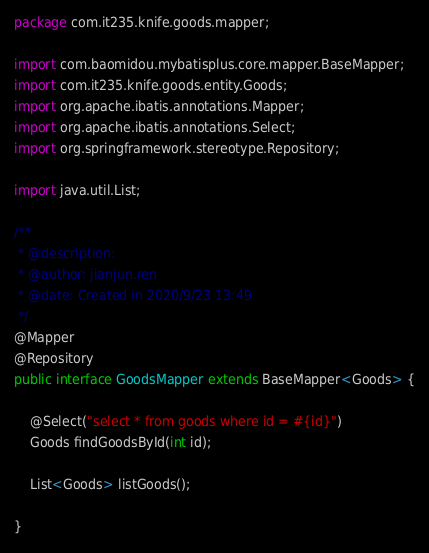<code> <loc_0><loc_0><loc_500><loc_500><_Java_>package com.it235.knife.goods.mapper;

import com.baomidou.mybatisplus.core.mapper.BaseMapper;
import com.it235.knife.goods.entity.Goods;
import org.apache.ibatis.annotations.Mapper;
import org.apache.ibatis.annotations.Select;
import org.springframework.stereotype.Repository;

import java.util.List;

/**
 * @description:
 * @author: jianjun.ren
 * @date: Created in 2020/9/23 13:49
 */
@Mapper
@Repository
public interface GoodsMapper extends BaseMapper<Goods> {

    @Select("select * from goods where id = #{id}")
    Goods findGoodsById(int id);

    List<Goods> listGoods();

}
</code> 